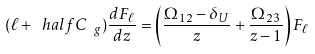Convert formula to latex. <formula><loc_0><loc_0><loc_500><loc_500>( \ell + \ h a l f { C _ { \ g } } ) \frac { d F _ { \ell } } { d z } = \left ( \frac { \Omega _ { 1 2 } - \delta _ { U } } { z } + \frac { \Omega _ { 2 3 } } { z - 1 } \right ) F _ { \ell }</formula> 